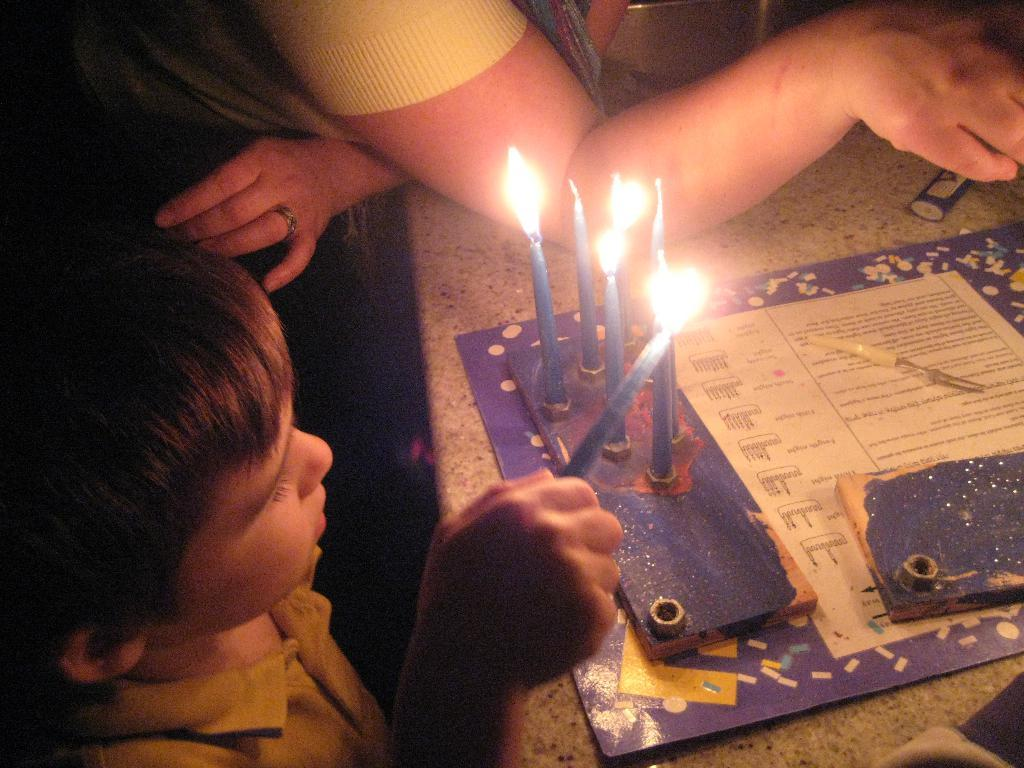What is the boy in the image doing? The boy is standing in the image and holding a candle. Who else is present in the image besides the boy? There is a person standing in the image. What is on the table in the image? There are candles and other objects on the table. How many candles are visible on the table? There are candles on the table, but the exact number is not specified. What holiday is being celebrated in the image? There is no indication of a holiday being celebrated in the image. What type of rhythm is the boy creating with the candle? The boy is not creating any rhythm with the candle in the image. 